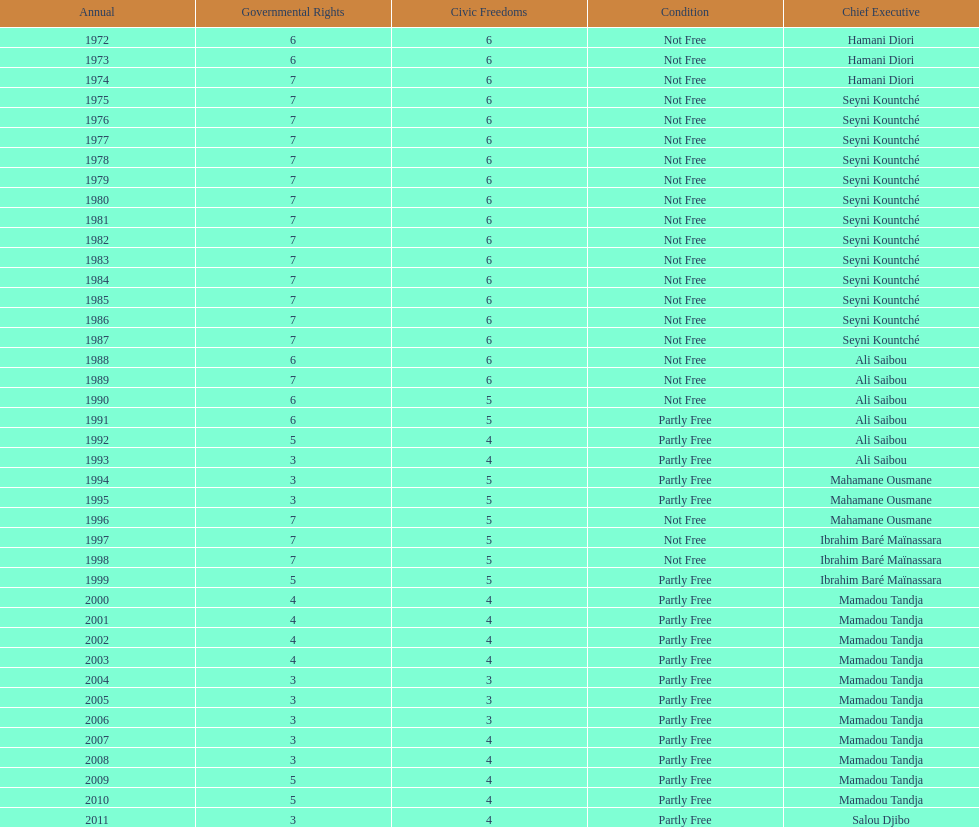Who was president before mamadou tandja? Ibrahim Baré Maïnassara. 